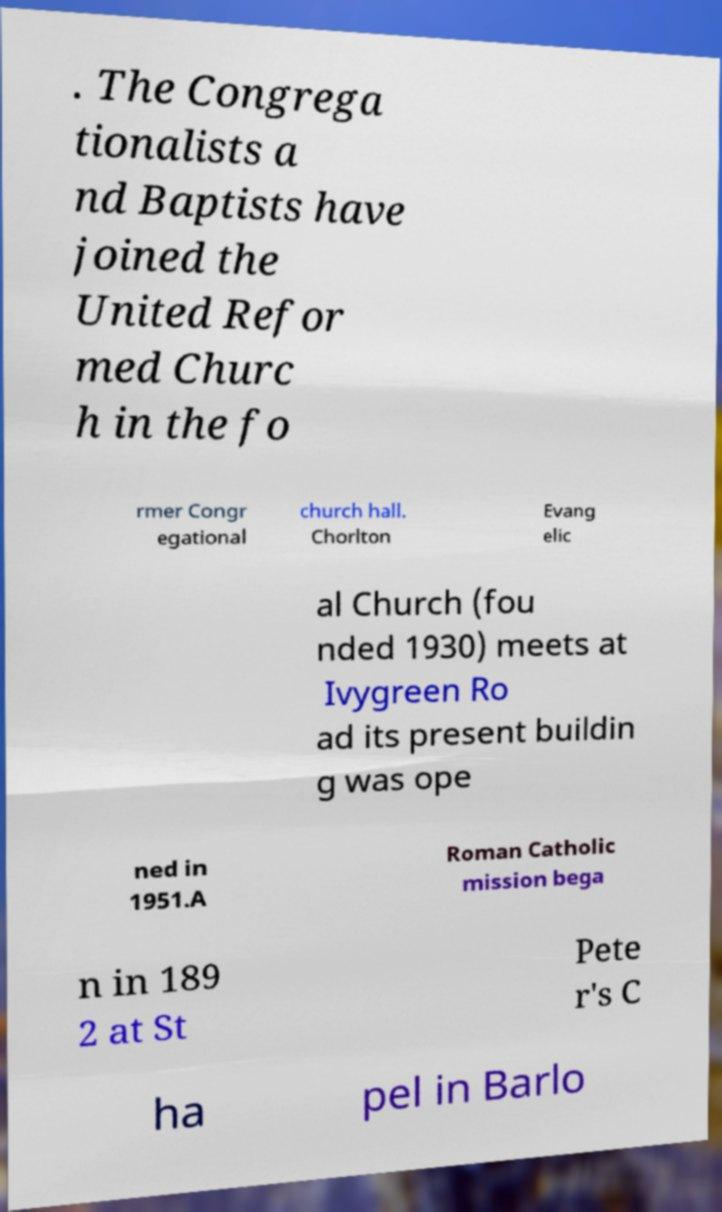What messages or text are displayed in this image? I need them in a readable, typed format. . The Congrega tionalists a nd Baptists have joined the United Refor med Churc h in the fo rmer Congr egational church hall. Chorlton Evang elic al Church (fou nded 1930) meets at Ivygreen Ro ad its present buildin g was ope ned in 1951.A Roman Catholic mission bega n in 189 2 at St Pete r's C ha pel in Barlo 